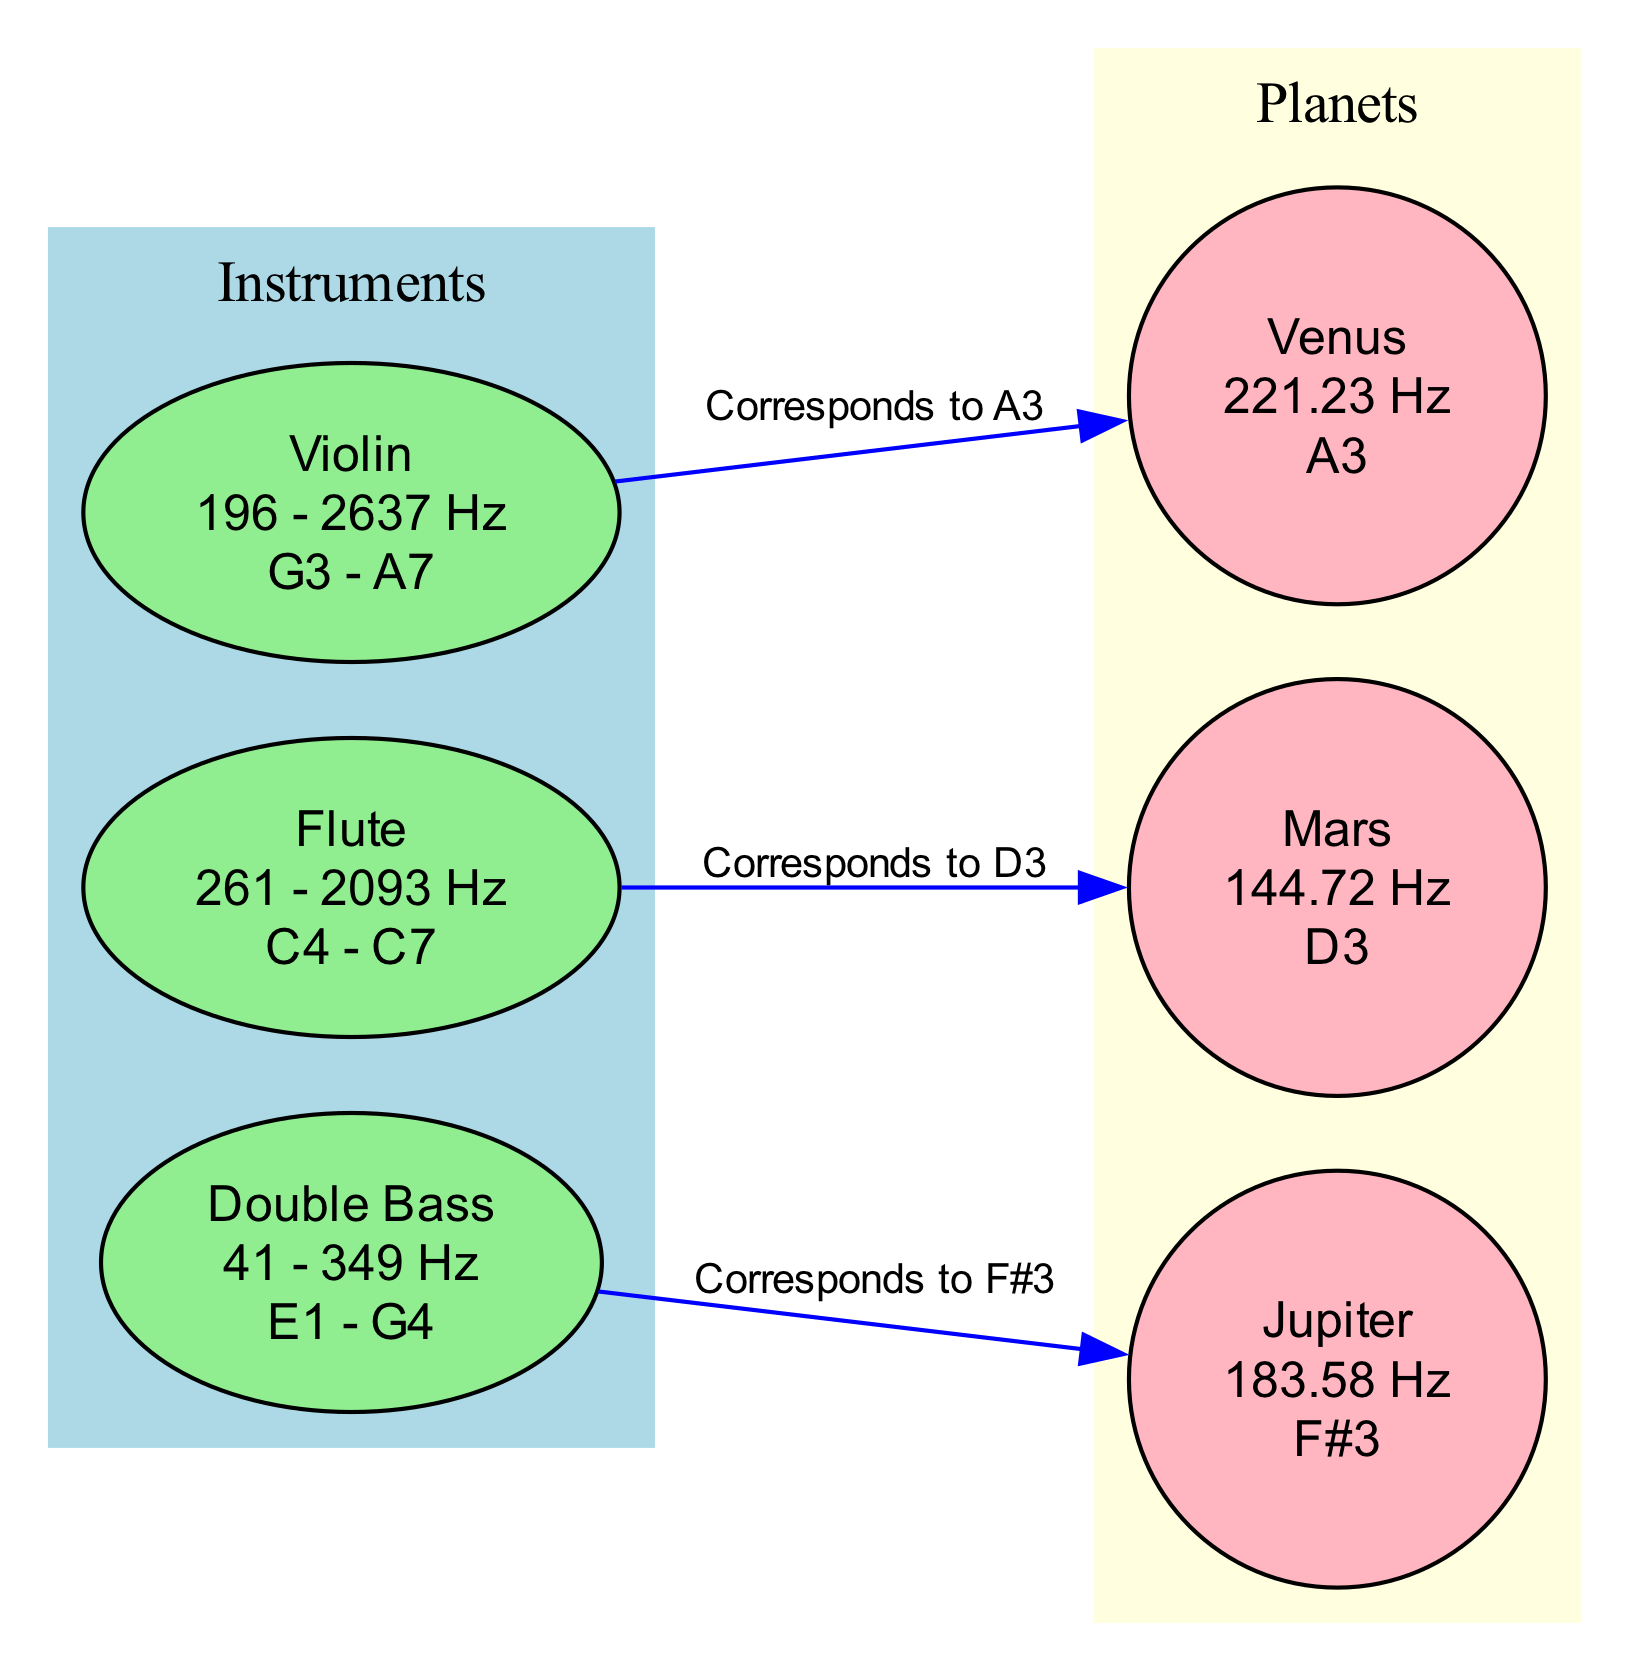What is the frequency range of the violin? The frequency range for the violin is clearly labeled in the diagram as "196 - 2637 Hz." Therefore, by identifying the node labeled "Violin," we can directly extract this information.
Answer: 196 - 2637 Hz Which planet corresponds to the flute's frequency? The diagram indicates a directed edge from the flute to Mars, labeled as "Corresponds to D3." This means the flute's frequency corresponds to the frequency of Mars, as it’s explicitly stated in the edge relationship between them.
Answer: Mars How many nodes are present in the diagram? The total count of nodes includes both instruments and planets listed in the data. There are three instruments (violin, flute, double bass) and three planets (Mars, Venus, Jupiter), summing to six nodes. By counting through the nodes provided in the data, we confirm the total.
Answer: 6 What is the frequency of Jupiter? The frequency of Jupiter is displayed in the diagram as "183.58 Hz." By locating the node labeled "Jupiter," we can retrieve this specific data directly.
Answer: 183.58 Hz Which instrument corresponds to the frequency of F#3? The edge that connects double bass to Jupiter is labeled "Corresponds to F#3." By tracing the edge from double bass to Jupiter on the diagram, it becomes clear that the instrument corresponding to F#3 is the double bass.
Answer: Double Bass What color represents the planets in the diagram? The diagram specifies that planets are represented using a light yellow fill color. By looking at the subgraph cluster labeled "Planets," we can observe their distinct color, which is uniformly light yellow.
Answer: Light yellow How are the instruments visually differentiated from the planets? Instruments are shown in a different fill color (light green) compared to planets (light yellow). Additionally, instruments are represented as ellipses while planets are represented as circles, contrasting the visual geometry of nodes. This differentiation is critical for understanding the structure of the diagram.
Answer: Instruments as ellipses and planets as circles What note corresponds to Venus? The diagram directly states that the note for Venus is "A3." By examining the node labeled "Venus" in the diagram, we can easily identify the corresponding note.
Answer: A3 